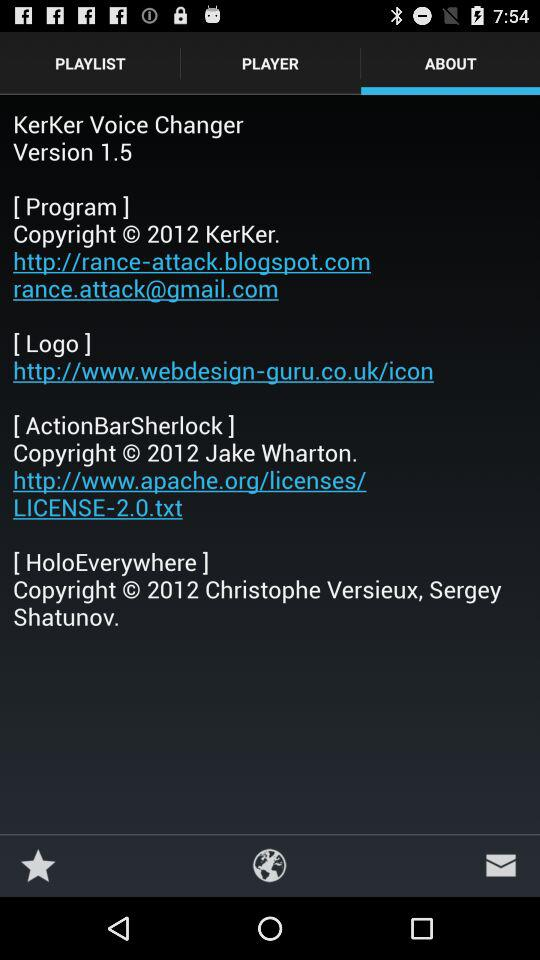Which files are in the playlist?
When the provided information is insufficient, respond with <no answer>. <no answer> 